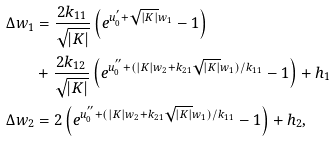Convert formula to latex. <formula><loc_0><loc_0><loc_500><loc_500>\Delta w _ { 1 } & = \frac { 2 k _ { 1 1 } } { \sqrt { | K | } } \left ( e ^ { u _ { 0 } ^ { ^ { \prime } } + \sqrt { | K | } w _ { 1 } } - 1 \right ) \\ & + \frac { 2 k _ { 1 2 } } { \sqrt { | K | } } \left ( e ^ { u _ { 0 } ^ { ^ { \prime \prime } } + ( | K | w _ { 2 } + k _ { 2 1 } \sqrt { | K | } w _ { 1 } ) / k _ { 1 1 } } - 1 \right ) + h _ { 1 } \\ \Delta w _ { 2 } & = 2 \left ( e ^ { u _ { 0 } ^ { ^ { \prime \prime } } + ( | K | w _ { 2 } + k _ { 2 1 } \sqrt { | K | } w _ { 1 } ) / k _ { 1 1 } } - 1 \right ) + h _ { 2 } ,</formula> 